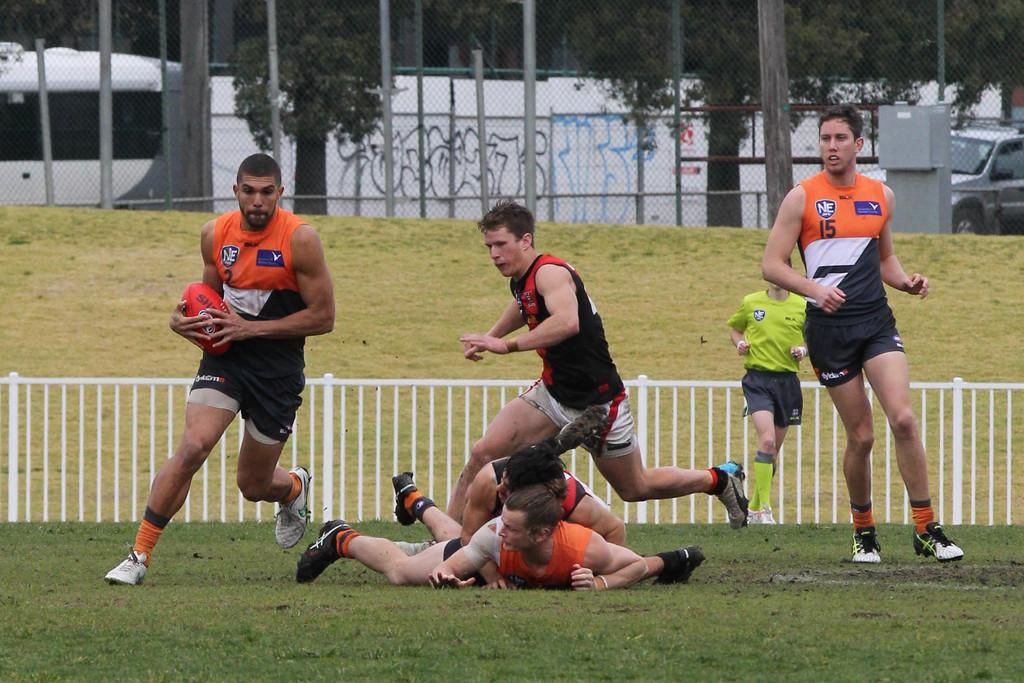<image>
Offer a succinct explanation of the picture presented. a player with a number 2 on his jersey runs with ball as a player with a number 15 jersey looks on 